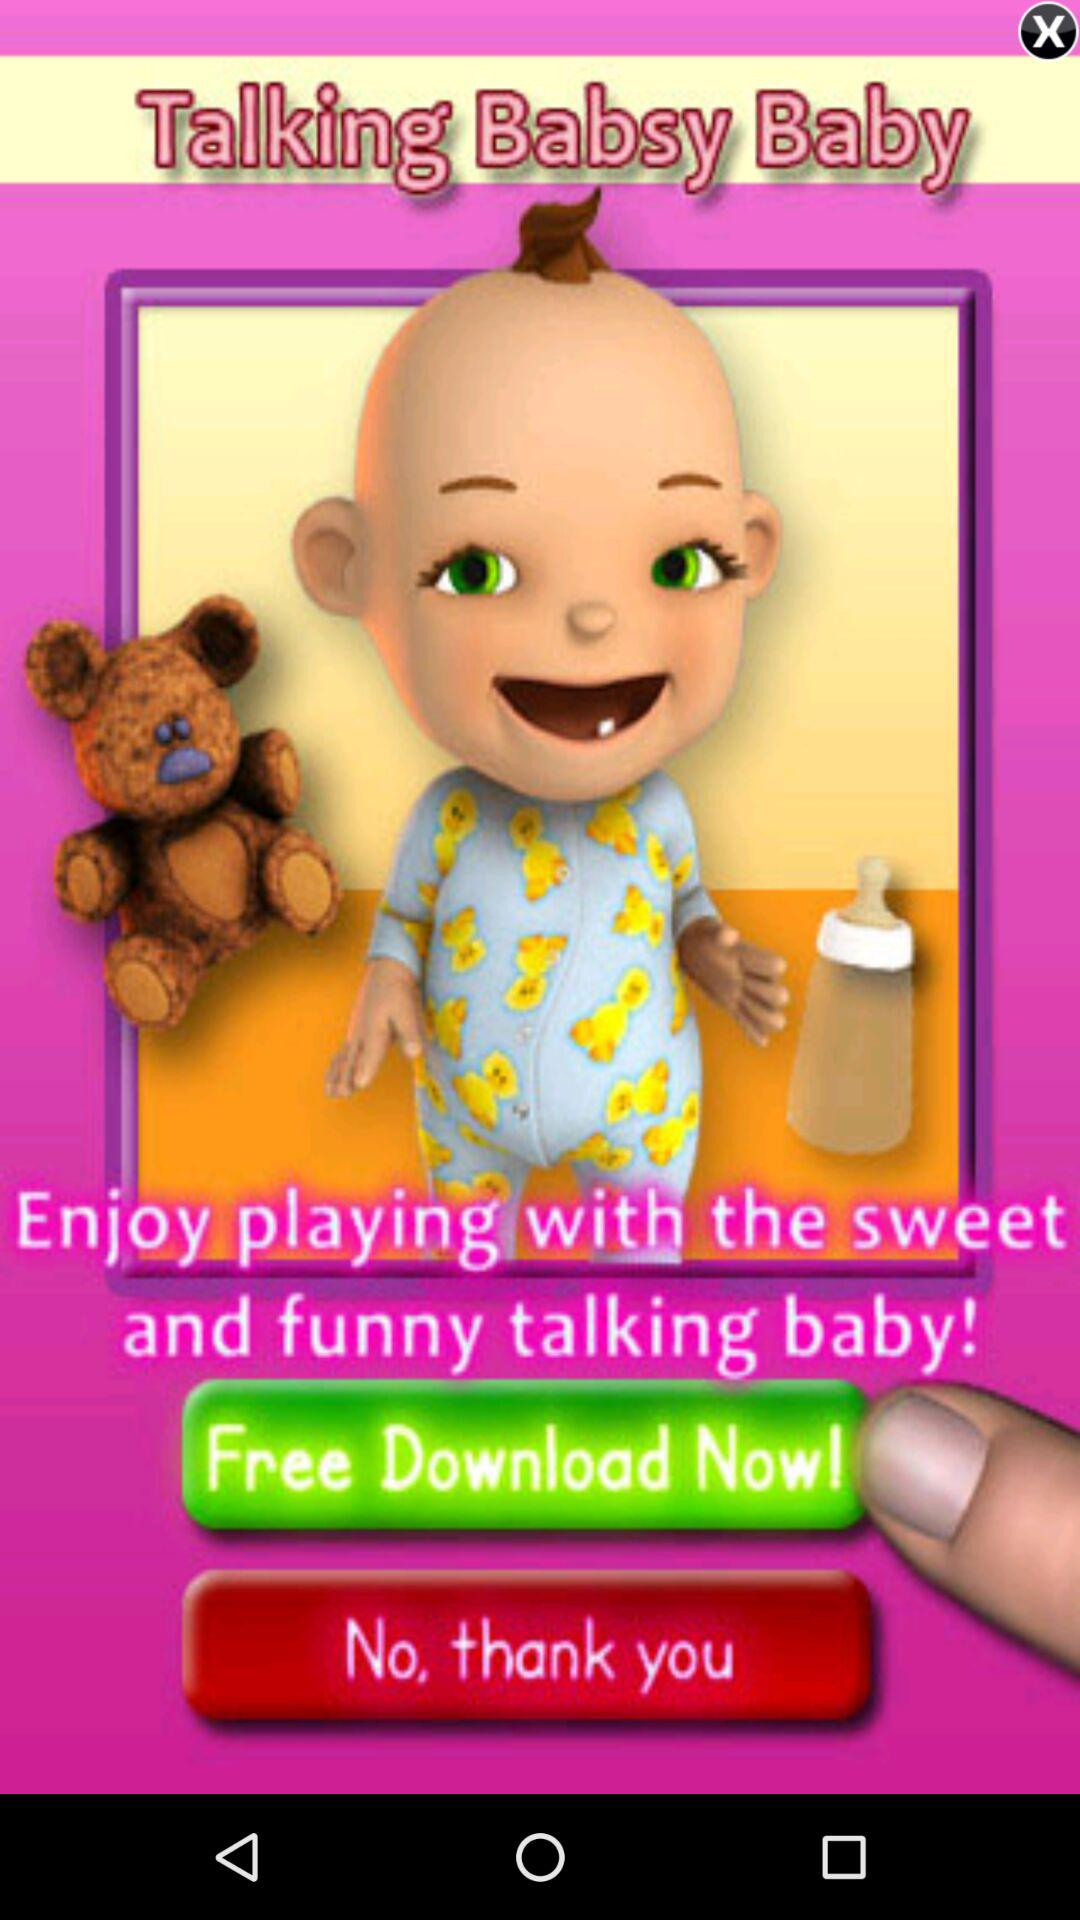What is the name of the application? The name of the application is "Talking Babsy Baby". 